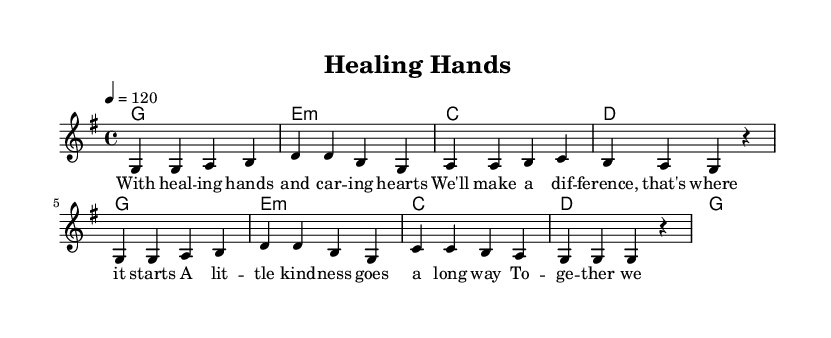What is the key signature of this music? The key signature is G major, which has one sharp (F#). This can be identified at the beginning of the staff where the sharps are indicated.
Answer: G major What is the time signature of this music? The time signature is 4/4, which is shown at the beginning of the score. This indicates there are four beats per measure and a quarter note gets one beat.
Answer: 4/4 What is the tempo marking of this music? The tempo marking is 120 beats per minute, indicated as "4 = 120" at the beginning. This indicates the speed at which the piece should be played.
Answer: 120 How many measures are in the melody line? By counting the groupings of notes, we can see there are eight measures in the melody line. Each measure is divided by vertical lines in the sheet music.
Answer: 8 What is the chord progression used in the first half of the piece? The chord progression in the first half consists of G, E minor, C, and D, which can be seen in the chord mode section of the score. This helps create the harmonic structure of the melody.
Answer: G, E minor, C, D What is the primary theme of the lyrics? The primary theme of the lyrics is about healing and kindness, as it emphasizes making a difference through caring actions. This can be understood by reading the provided lyrics.
Answer: Healing and kindness What kind of voice is used for the melody? The melody is written for a single voice, as indicated by "new Voice = 'one'" in the score. This implies that it is meant to be sung solo.
Answer: Solo voice 